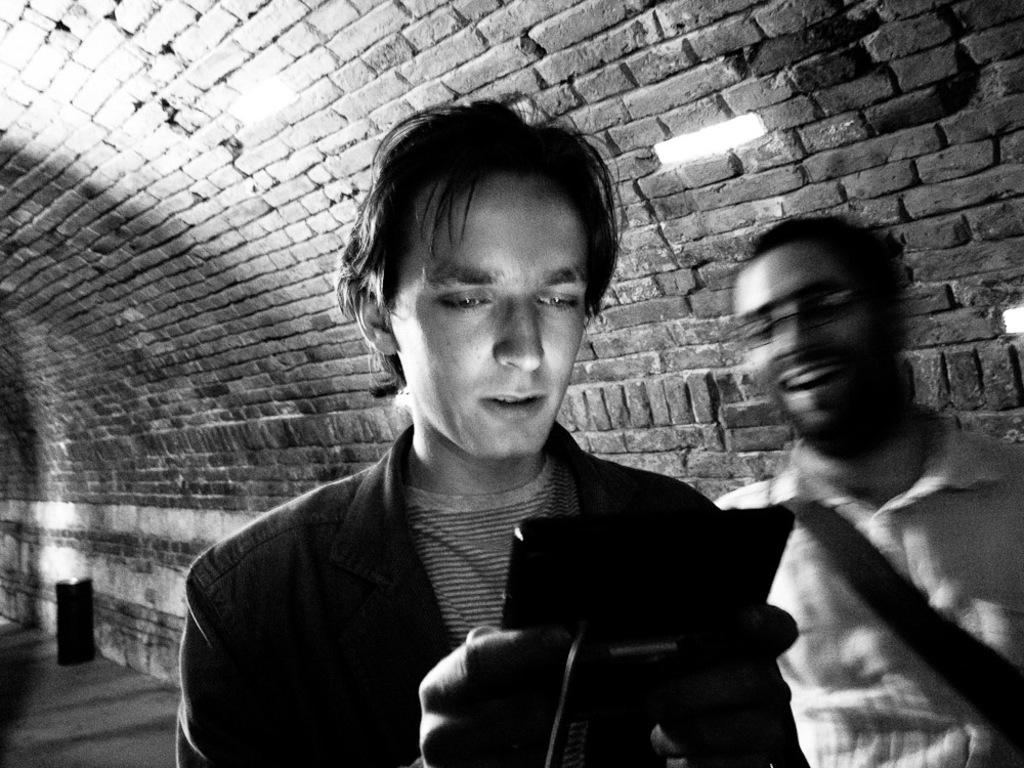How many people are wearing dresses in the image? There are two people with dresses in the image. What is one person doing with their hands in the image? One person is holding an object in the image. What can be seen behind the people in the image? There is a brick wall in the background of the image. What color scheme is used in the image? The image is black and white. What type of baseball equipment can be seen in the image? There is no baseball equipment present in the image. How does the sponge absorb water in the image? There is no sponge present in the image. 